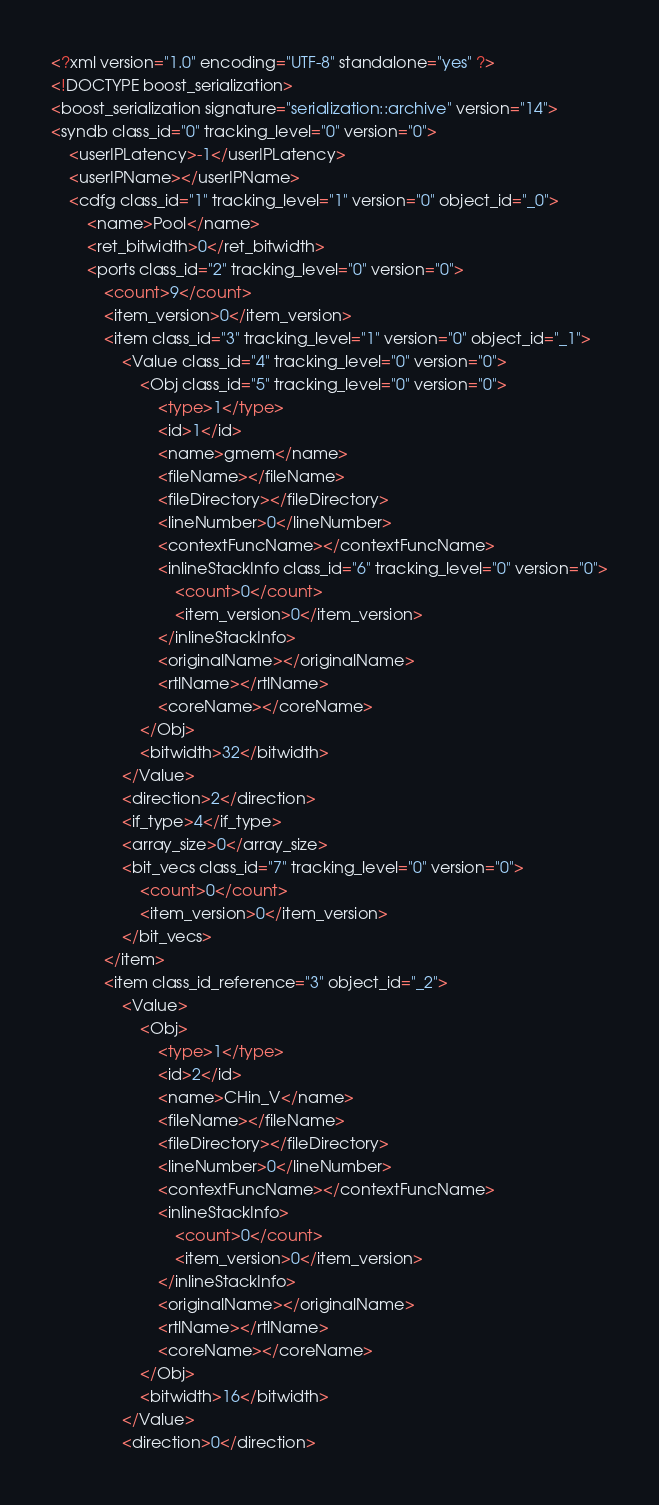Convert code to text. <code><loc_0><loc_0><loc_500><loc_500><_Ada_><?xml version="1.0" encoding="UTF-8" standalone="yes" ?>
<!DOCTYPE boost_serialization>
<boost_serialization signature="serialization::archive" version="14">
<syndb class_id="0" tracking_level="0" version="0">
	<userIPLatency>-1</userIPLatency>
	<userIPName></userIPName>
	<cdfg class_id="1" tracking_level="1" version="0" object_id="_0">
		<name>Pool</name>
		<ret_bitwidth>0</ret_bitwidth>
		<ports class_id="2" tracking_level="0" version="0">
			<count>9</count>
			<item_version>0</item_version>
			<item class_id="3" tracking_level="1" version="0" object_id="_1">
				<Value class_id="4" tracking_level="0" version="0">
					<Obj class_id="5" tracking_level="0" version="0">
						<type>1</type>
						<id>1</id>
						<name>gmem</name>
						<fileName></fileName>
						<fileDirectory></fileDirectory>
						<lineNumber>0</lineNumber>
						<contextFuncName></contextFuncName>
						<inlineStackInfo class_id="6" tracking_level="0" version="0">
							<count>0</count>
							<item_version>0</item_version>
						</inlineStackInfo>
						<originalName></originalName>
						<rtlName></rtlName>
						<coreName></coreName>
					</Obj>
					<bitwidth>32</bitwidth>
				</Value>
				<direction>2</direction>
				<if_type>4</if_type>
				<array_size>0</array_size>
				<bit_vecs class_id="7" tracking_level="0" version="0">
					<count>0</count>
					<item_version>0</item_version>
				</bit_vecs>
			</item>
			<item class_id_reference="3" object_id="_2">
				<Value>
					<Obj>
						<type>1</type>
						<id>2</id>
						<name>CHin_V</name>
						<fileName></fileName>
						<fileDirectory></fileDirectory>
						<lineNumber>0</lineNumber>
						<contextFuncName></contextFuncName>
						<inlineStackInfo>
							<count>0</count>
							<item_version>0</item_version>
						</inlineStackInfo>
						<originalName></originalName>
						<rtlName></rtlName>
						<coreName></coreName>
					</Obj>
					<bitwidth>16</bitwidth>
				</Value>
				<direction>0</direction></code> 